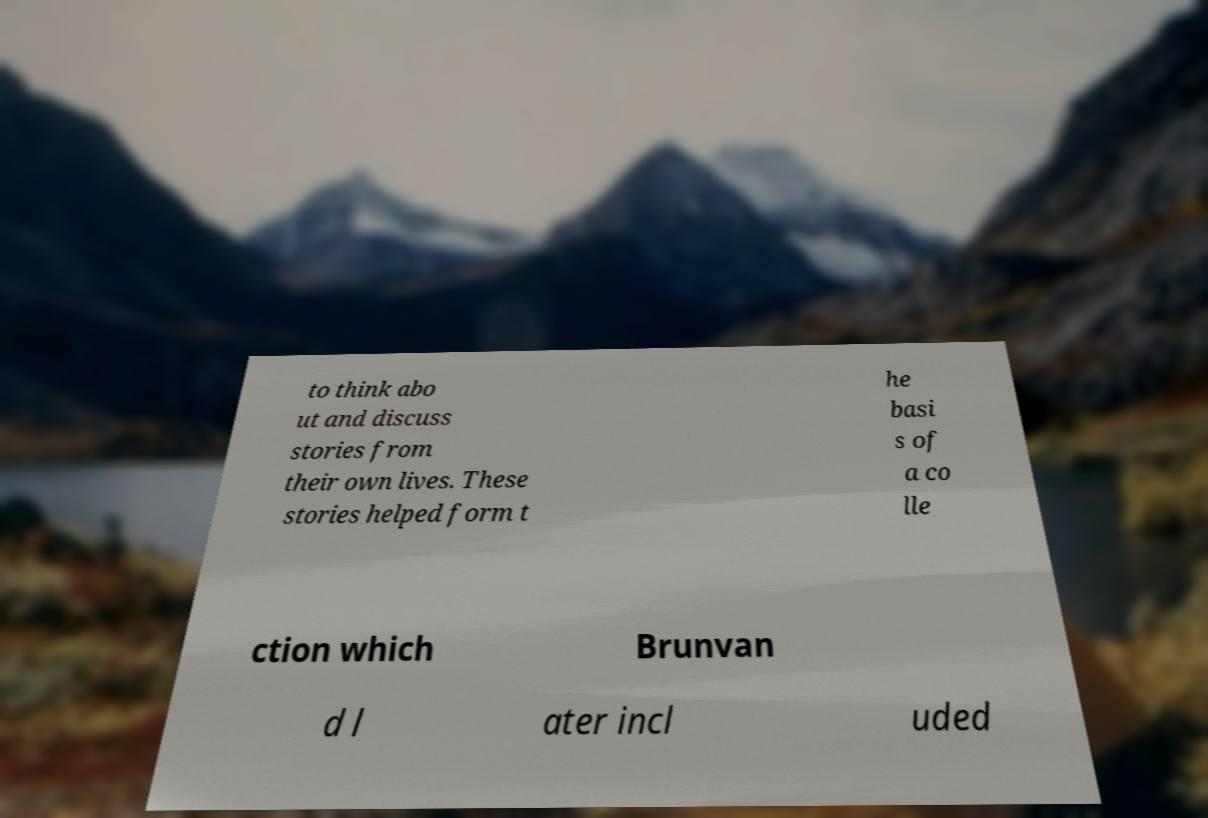Could you extract and type out the text from this image? to think abo ut and discuss stories from their own lives. These stories helped form t he basi s of a co lle ction which Brunvan d l ater incl uded 